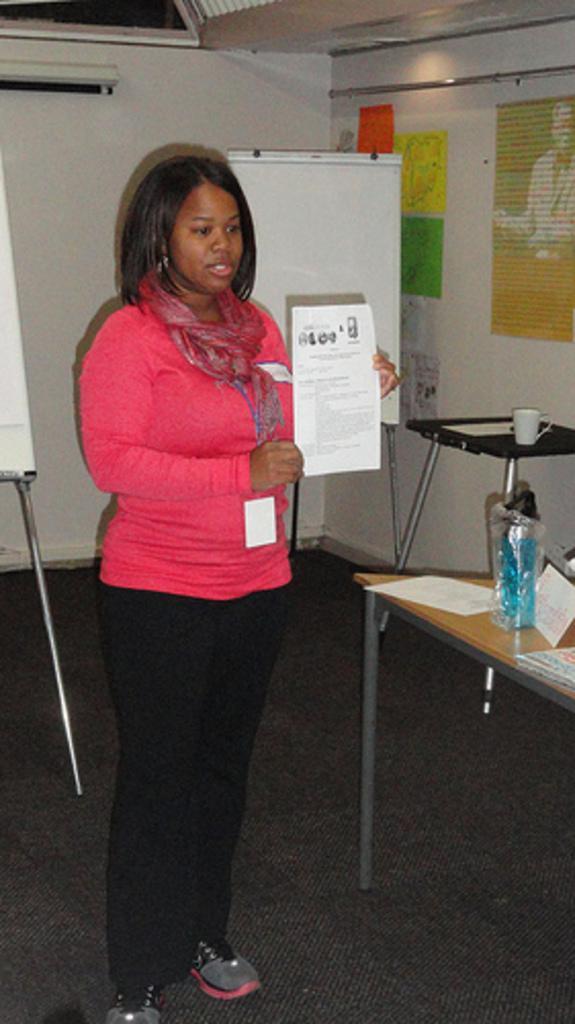How would you summarize this image in a sentence or two? In the picture I can see a woman wearing pink color, black color pant also wearing ID card standing and holding a paper in her hands, on right side of the picture there is table on which there is bottle, there are some papers, in the background of the picture there is board, wall to which some posters are attached. 